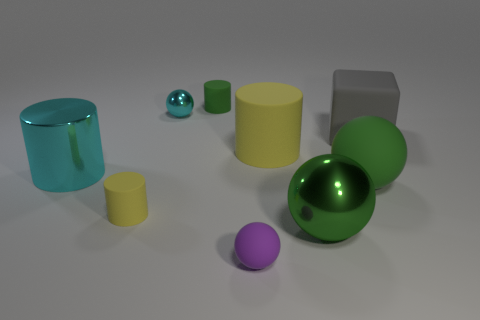There is a large object that is the same color as the large metallic ball; what shape is it?
Offer a terse response. Sphere. Is the big shiny sphere the same color as the large matte ball?
Your answer should be very brief. Yes. How many cylinders are either tiny yellow things or large shiny objects?
Provide a short and direct response. 2. What is the material of the tiny thing that is behind the purple thing and in front of the gray cube?
Give a very brief answer. Rubber. What number of large gray matte cubes are behind the large gray object?
Keep it short and to the point. 0. Does the tiny sphere behind the green metal sphere have the same material as the cylinder that is behind the big cube?
Offer a terse response. No. How many objects are either small rubber things that are on the left side of the tiny purple object or big matte spheres?
Keep it short and to the point. 3. Is the number of shiny cylinders that are behind the big rubber cube less than the number of things that are behind the small matte ball?
Your answer should be compact. Yes. What number of other objects are the same size as the purple matte sphere?
Your response must be concise. 3. Are the small cyan ball and the big thing that is on the left side of the small cyan shiny object made of the same material?
Offer a terse response. Yes. 